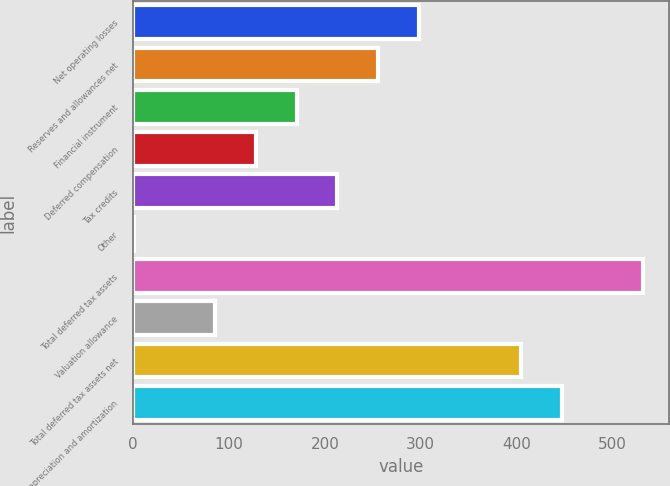Convert chart. <chart><loc_0><loc_0><loc_500><loc_500><bar_chart><fcel>Net operating losses<fcel>Reserves and allowances net<fcel>Financial instrument<fcel>Deferred compensation<fcel>Tax credits<fcel>Other<fcel>Total deferred tax assets<fcel>Valuation allowance<fcel>Total deferred tax assets net<fcel>Depreciation and amortization<nl><fcel>297.8<fcel>255.4<fcel>170.6<fcel>128.2<fcel>213<fcel>1<fcel>532.2<fcel>85.8<fcel>405<fcel>447.4<nl></chart> 